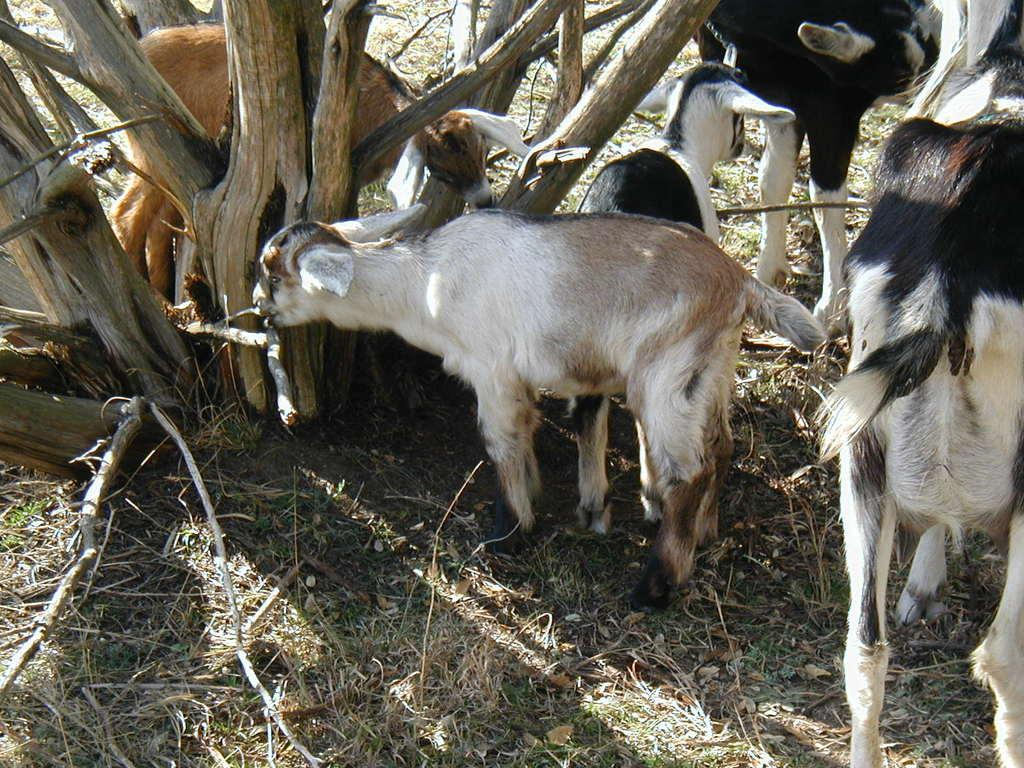What type of animals are present in the image? There are sheeps in the image. What type of vegetation can be seen in the image? There is dry grass in the image. What other object can be seen in the image besides the sheeps and dry grass? There is a tree stem in the image. How many basketballs can be seen in the image? There are no basketballs present in the image. What type of things are the sheeps using to play in the image? The sheeps are not playing with any objects in the image, as they are grazing on the dry grass. 